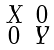<formula> <loc_0><loc_0><loc_500><loc_500>\begin{smallmatrix} X & 0 \\ 0 & Y \end{smallmatrix}</formula> 